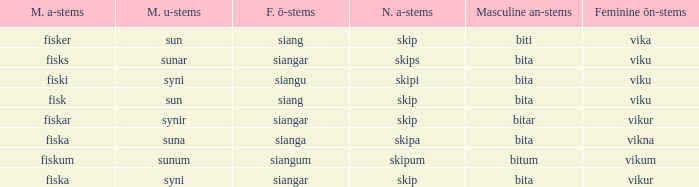What is the u form of the word with a neuter form of skip and a masculine a-ending of fisker? Sun. 